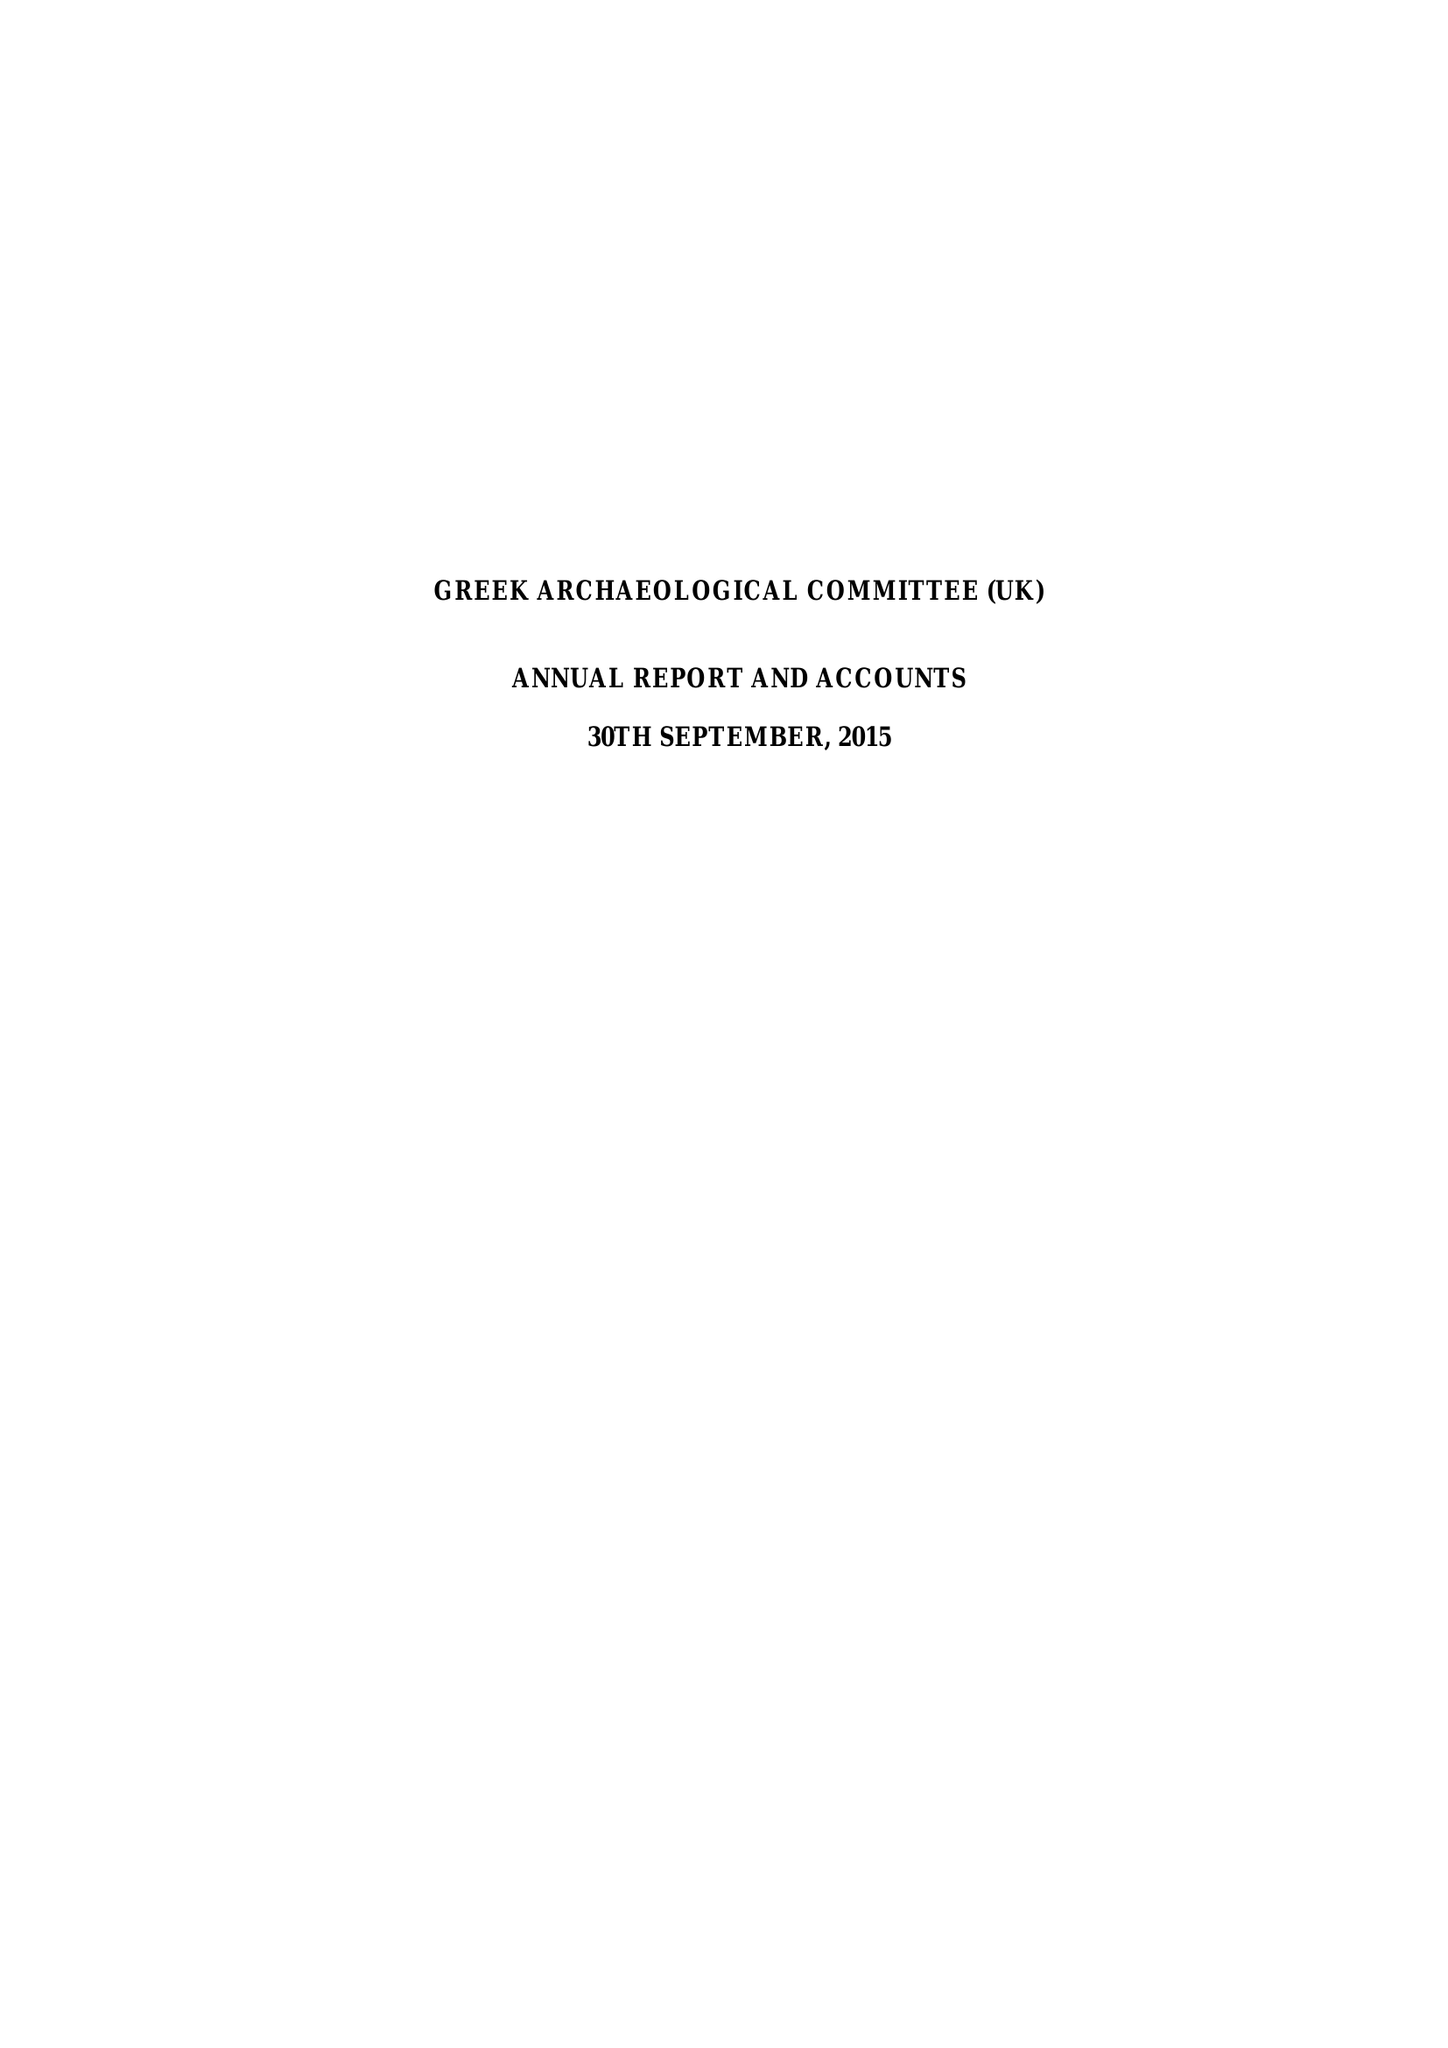What is the value for the address__post_town?
Answer the question using a single word or phrase. LONDON 